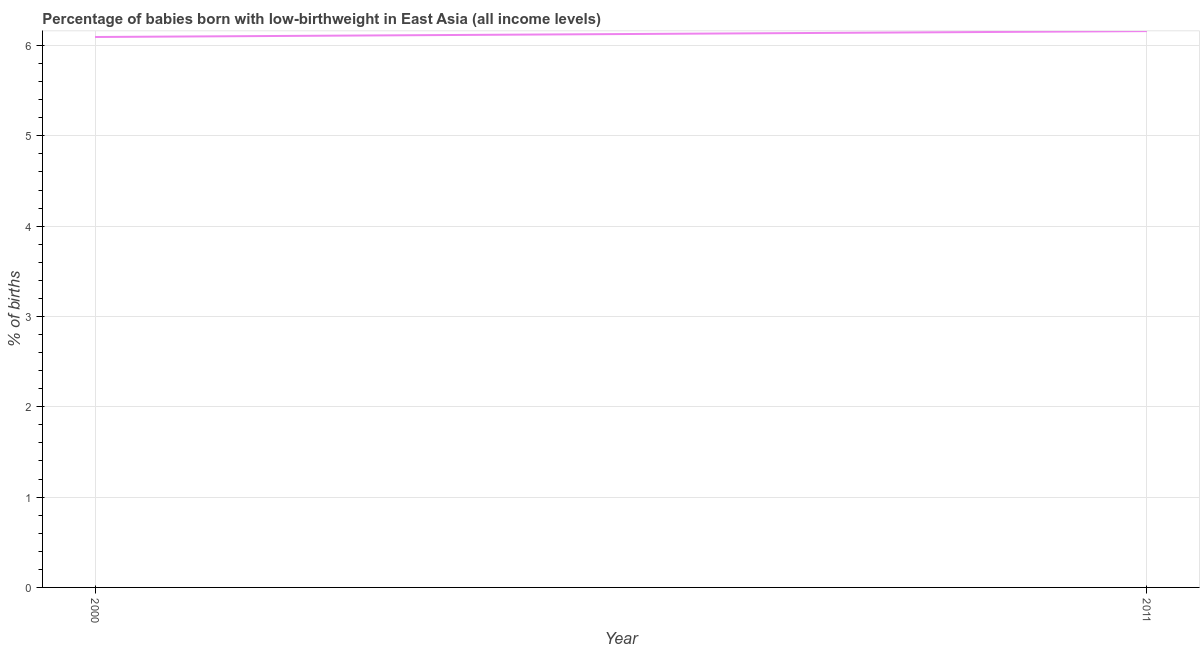What is the percentage of babies who were born with low-birthweight in 2011?
Offer a very short reply. 6.16. Across all years, what is the maximum percentage of babies who were born with low-birthweight?
Your answer should be very brief. 6.16. Across all years, what is the minimum percentage of babies who were born with low-birthweight?
Provide a succinct answer. 6.09. What is the sum of the percentage of babies who were born with low-birthweight?
Offer a very short reply. 12.25. What is the difference between the percentage of babies who were born with low-birthweight in 2000 and 2011?
Your response must be concise. -0.07. What is the average percentage of babies who were born with low-birthweight per year?
Your answer should be compact. 6.13. What is the median percentage of babies who were born with low-birthweight?
Ensure brevity in your answer.  6.13. Do a majority of the years between 2011 and 2000 (inclusive) have percentage of babies who were born with low-birthweight greater than 4 %?
Ensure brevity in your answer.  No. What is the ratio of the percentage of babies who were born with low-birthweight in 2000 to that in 2011?
Offer a very short reply. 0.99. Is the percentage of babies who were born with low-birthweight in 2000 less than that in 2011?
Your answer should be compact. Yes. How many years are there in the graph?
Ensure brevity in your answer.  2. Are the values on the major ticks of Y-axis written in scientific E-notation?
Offer a terse response. No. What is the title of the graph?
Make the answer very short. Percentage of babies born with low-birthweight in East Asia (all income levels). What is the label or title of the X-axis?
Provide a succinct answer. Year. What is the label or title of the Y-axis?
Your response must be concise. % of births. What is the % of births in 2000?
Provide a short and direct response. 6.09. What is the % of births of 2011?
Provide a short and direct response. 6.16. What is the difference between the % of births in 2000 and 2011?
Provide a short and direct response. -0.07. What is the ratio of the % of births in 2000 to that in 2011?
Provide a short and direct response. 0.99. 